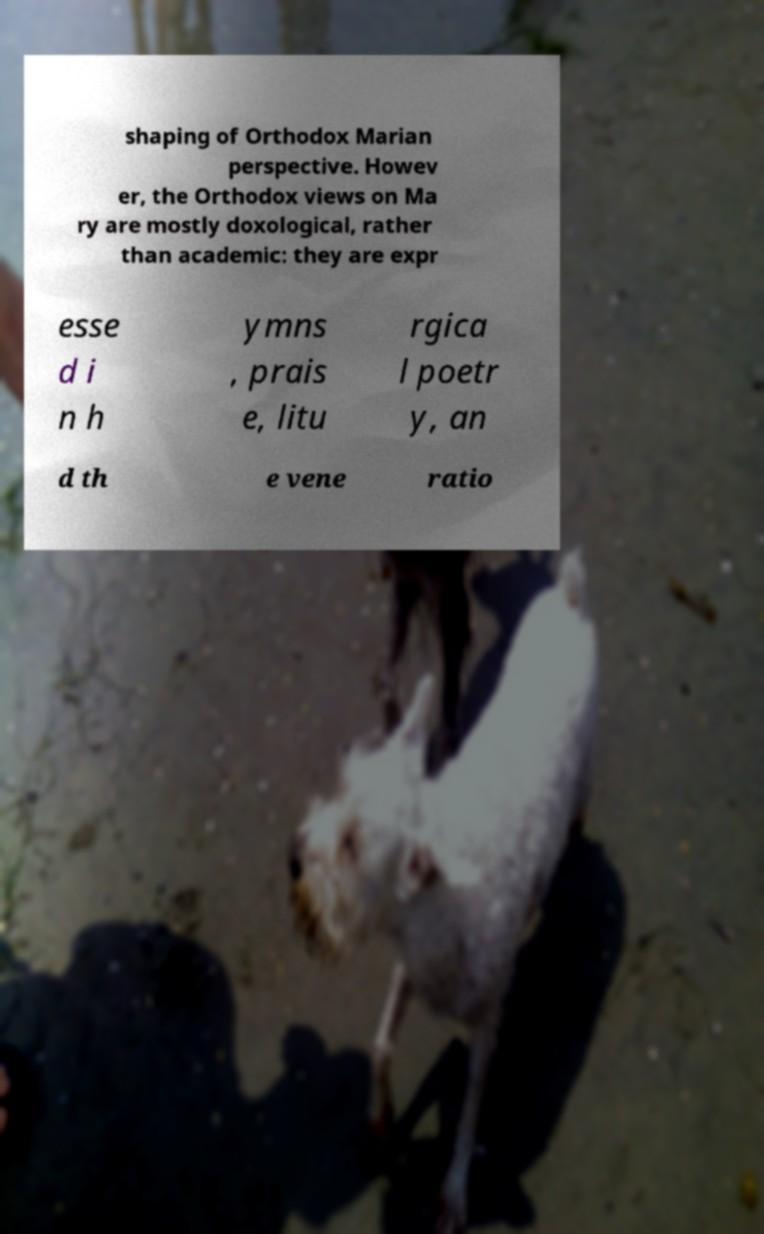Could you assist in decoding the text presented in this image and type it out clearly? shaping of Orthodox Marian perspective. Howev er, the Orthodox views on Ma ry are mostly doxological, rather than academic: they are expr esse d i n h ymns , prais e, litu rgica l poetr y, an d th e vene ratio 